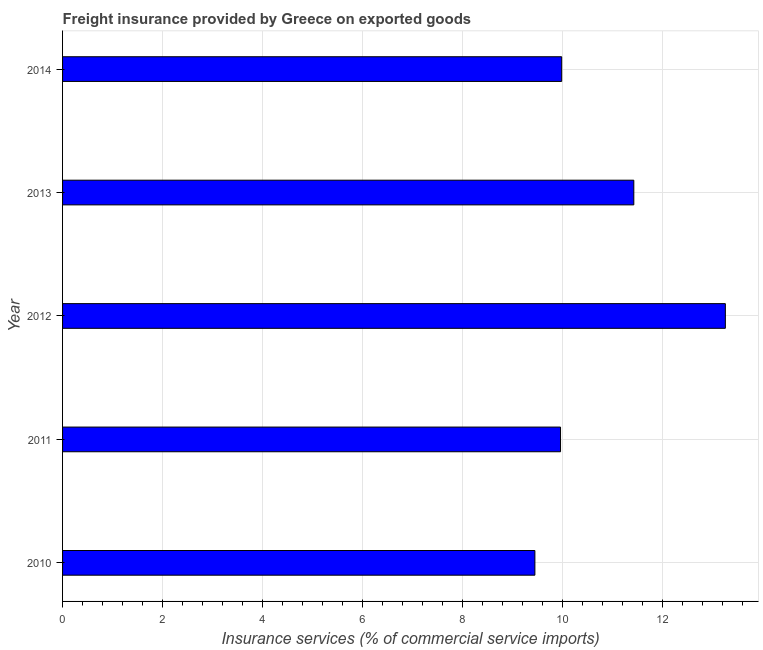Does the graph contain any zero values?
Keep it short and to the point. No. What is the title of the graph?
Your response must be concise. Freight insurance provided by Greece on exported goods . What is the label or title of the X-axis?
Offer a very short reply. Insurance services (% of commercial service imports). What is the label or title of the Y-axis?
Your answer should be compact. Year. What is the freight insurance in 2012?
Keep it short and to the point. 13.25. Across all years, what is the maximum freight insurance?
Ensure brevity in your answer.  13.25. Across all years, what is the minimum freight insurance?
Provide a short and direct response. 9.45. In which year was the freight insurance maximum?
Your answer should be compact. 2012. What is the sum of the freight insurance?
Give a very brief answer. 54.06. What is the difference between the freight insurance in 2012 and 2013?
Offer a terse response. 1.83. What is the average freight insurance per year?
Ensure brevity in your answer.  10.81. What is the median freight insurance?
Your answer should be very brief. 9.98. What is the ratio of the freight insurance in 2010 to that in 2013?
Offer a terse response. 0.83. Is the freight insurance in 2010 less than that in 2011?
Give a very brief answer. Yes. Is the difference between the freight insurance in 2010 and 2011 greater than the difference between any two years?
Make the answer very short. No. What is the difference between the highest and the second highest freight insurance?
Make the answer very short. 1.83. Is the sum of the freight insurance in 2011 and 2014 greater than the maximum freight insurance across all years?
Make the answer very short. Yes. What is the difference between the highest and the lowest freight insurance?
Provide a succinct answer. 3.81. Are all the bars in the graph horizontal?
Provide a short and direct response. Yes. How many years are there in the graph?
Your answer should be compact. 5. Are the values on the major ticks of X-axis written in scientific E-notation?
Make the answer very short. No. What is the Insurance services (% of commercial service imports) of 2010?
Your response must be concise. 9.45. What is the Insurance services (% of commercial service imports) in 2011?
Make the answer very short. 9.96. What is the Insurance services (% of commercial service imports) of 2012?
Your answer should be compact. 13.25. What is the Insurance services (% of commercial service imports) of 2013?
Offer a terse response. 11.42. What is the Insurance services (% of commercial service imports) in 2014?
Your answer should be very brief. 9.98. What is the difference between the Insurance services (% of commercial service imports) in 2010 and 2011?
Offer a very short reply. -0.51. What is the difference between the Insurance services (% of commercial service imports) in 2010 and 2012?
Ensure brevity in your answer.  -3.81. What is the difference between the Insurance services (% of commercial service imports) in 2010 and 2013?
Offer a very short reply. -1.98. What is the difference between the Insurance services (% of commercial service imports) in 2010 and 2014?
Keep it short and to the point. -0.54. What is the difference between the Insurance services (% of commercial service imports) in 2011 and 2012?
Make the answer very short. -3.3. What is the difference between the Insurance services (% of commercial service imports) in 2011 and 2013?
Offer a very short reply. -1.47. What is the difference between the Insurance services (% of commercial service imports) in 2011 and 2014?
Ensure brevity in your answer.  -0.02. What is the difference between the Insurance services (% of commercial service imports) in 2012 and 2013?
Your answer should be very brief. 1.83. What is the difference between the Insurance services (% of commercial service imports) in 2012 and 2014?
Ensure brevity in your answer.  3.27. What is the difference between the Insurance services (% of commercial service imports) in 2013 and 2014?
Ensure brevity in your answer.  1.44. What is the ratio of the Insurance services (% of commercial service imports) in 2010 to that in 2011?
Your answer should be very brief. 0.95. What is the ratio of the Insurance services (% of commercial service imports) in 2010 to that in 2012?
Your response must be concise. 0.71. What is the ratio of the Insurance services (% of commercial service imports) in 2010 to that in 2013?
Offer a terse response. 0.83. What is the ratio of the Insurance services (% of commercial service imports) in 2010 to that in 2014?
Your answer should be very brief. 0.95. What is the ratio of the Insurance services (% of commercial service imports) in 2011 to that in 2012?
Provide a short and direct response. 0.75. What is the ratio of the Insurance services (% of commercial service imports) in 2011 to that in 2013?
Offer a terse response. 0.87. What is the ratio of the Insurance services (% of commercial service imports) in 2012 to that in 2013?
Provide a short and direct response. 1.16. What is the ratio of the Insurance services (% of commercial service imports) in 2012 to that in 2014?
Offer a terse response. 1.33. What is the ratio of the Insurance services (% of commercial service imports) in 2013 to that in 2014?
Your response must be concise. 1.15. 